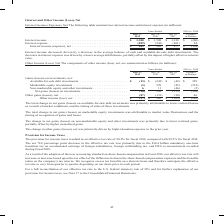According to Cisco Systems's financial document, What was the  total change in net gains (losses) on marketable equity investments attributable to? market value fluctuations and the timing of recognition of gains and losses.. The document states: "marketable equity investments was attributable to market value fluctuations and the timing of recognition of gains and losses...." Also, What was the change in net gains (losses) on non-marketable equity and other investments primarily due to? lower realized gains, partially offset by higher unrealized gains.. The document states: "equity and other investments was primarily due to lower realized gains, partially offset by higher unrealized gains...." Also, Which years does the table provide information for the components of net other income (loss)? The document contains multiple relevant values: 2019, 2018, 2017. From the document: "019 vs. 2018 July 27, 2019 July 28, 2018 July 29, 2017 Variance in Dollars Interest income . $ 1,308 $ 1,508 $ 1,338 $ (200) Interest expense . (859) ..." Also, can you calculate: What was the change in Non-marketable equity and other investments between 2017 and 2018? Based on the calculation: 11-(-46), the result is 57 (in millions). This is based on the information: ") Non-marketable equity and other investments . 6 11 (46) (5) Net gains (losses) on investments . (10) 298 (133) (308) Other gains (losses), net. . (87) n-marketable equity and other investments . 6 1..." The key data points involved are: 11, 46. Also, can you calculate: What was the difference in the variance in dollars between Available-for-sale debt investments and net Other gains (losses)? Based on the calculation: 229-46, the result is 183 (in millions). This is based on the information: "-sale debt investments. . $ (13) $ (242) $ (42) $ 229 Marketable equity investments . (3) 529 (45) (532) Non-marketable equity and other investments . 6 n-marketable equity and other investments . 6 1..." The key data points involved are: 229, 46. Also, can you calculate: What was the percentage change in the net other gains (losses) between 2017 and 2018? To answer this question, I need to perform calculations using the financial data. The calculation is: (-133-(-30))/-30, which equals 343.33 (percentage). This is based on the information: "3) (308) Other gains (losses), net. . (87) (133) (30) 46 Other income (loss), net . $ (97) $ 165 $ (163) $ (262) (5) Net gains (losses) on investments . (10) 298 (133) (308) Other gains (losses), net...." The key data points involved are: 133, 30. 